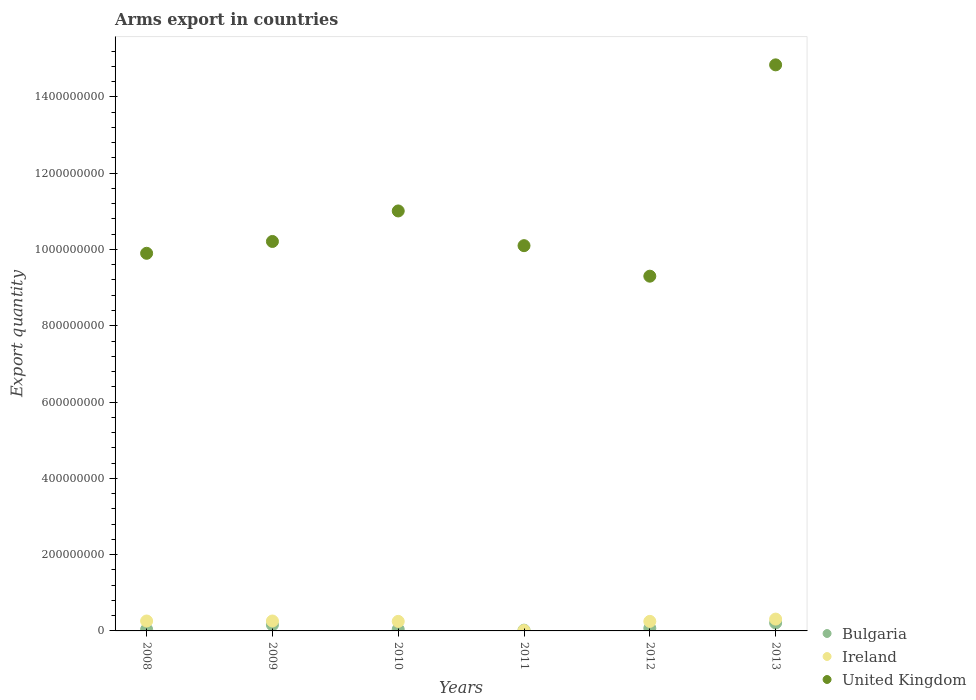How many different coloured dotlines are there?
Give a very brief answer. 3. What is the total arms export in United Kingdom in 2012?
Your response must be concise. 9.30e+08. Across all years, what is the maximum total arms export in Bulgaria?
Provide a short and direct response. 2.10e+07. Across all years, what is the minimum total arms export in Bulgaria?
Ensure brevity in your answer.  2.00e+06. In which year was the total arms export in Bulgaria maximum?
Provide a succinct answer. 2013. What is the total total arms export in United Kingdom in the graph?
Provide a succinct answer. 6.54e+09. What is the difference between the total arms export in United Kingdom in 2010 and that in 2011?
Offer a terse response. 9.10e+07. What is the difference between the total arms export in Bulgaria in 2011 and the total arms export in Ireland in 2009?
Keep it short and to the point. -2.40e+07. What is the average total arms export in Bulgaria per year?
Provide a succinct answer. 9.00e+06. In the year 2011, what is the difference between the total arms export in United Kingdom and total arms export in Ireland?
Ensure brevity in your answer.  1.01e+09. What is the ratio of the total arms export in Bulgaria in 2009 to that in 2012?
Offer a very short reply. 2.29. What is the difference between the highest and the second highest total arms export in Ireland?
Give a very brief answer. 5.00e+06. What is the difference between the highest and the lowest total arms export in United Kingdom?
Ensure brevity in your answer.  5.54e+08. In how many years, is the total arms export in Ireland greater than the average total arms export in Ireland taken over all years?
Offer a very short reply. 5. Is it the case that in every year, the sum of the total arms export in United Kingdom and total arms export in Ireland  is greater than the total arms export in Bulgaria?
Offer a very short reply. Yes. Is the total arms export in Bulgaria strictly less than the total arms export in Ireland over the years?
Provide a short and direct response. No. How many dotlines are there?
Provide a succinct answer. 3. Are the values on the major ticks of Y-axis written in scientific E-notation?
Your answer should be compact. No. Does the graph contain grids?
Keep it short and to the point. No. How are the legend labels stacked?
Keep it short and to the point. Vertical. What is the title of the graph?
Ensure brevity in your answer.  Arms export in countries. What is the label or title of the X-axis?
Offer a terse response. Years. What is the label or title of the Y-axis?
Your answer should be very brief. Export quantity. What is the Export quantity in Bulgaria in 2008?
Your answer should be compact. 4.00e+06. What is the Export quantity in Ireland in 2008?
Offer a very short reply. 2.60e+07. What is the Export quantity of United Kingdom in 2008?
Your response must be concise. 9.90e+08. What is the Export quantity of Bulgaria in 2009?
Provide a short and direct response. 1.60e+07. What is the Export quantity of Ireland in 2009?
Provide a succinct answer. 2.60e+07. What is the Export quantity of United Kingdom in 2009?
Provide a short and direct response. 1.02e+09. What is the Export quantity of Bulgaria in 2010?
Your answer should be very brief. 4.00e+06. What is the Export quantity of Ireland in 2010?
Make the answer very short. 2.50e+07. What is the Export quantity in United Kingdom in 2010?
Your answer should be very brief. 1.10e+09. What is the Export quantity in Ireland in 2011?
Give a very brief answer. 1.00e+06. What is the Export quantity of United Kingdom in 2011?
Make the answer very short. 1.01e+09. What is the Export quantity of Ireland in 2012?
Ensure brevity in your answer.  2.50e+07. What is the Export quantity in United Kingdom in 2012?
Provide a succinct answer. 9.30e+08. What is the Export quantity of Bulgaria in 2013?
Your answer should be very brief. 2.10e+07. What is the Export quantity of Ireland in 2013?
Your response must be concise. 3.10e+07. What is the Export quantity in United Kingdom in 2013?
Make the answer very short. 1.48e+09. Across all years, what is the maximum Export quantity of Bulgaria?
Offer a very short reply. 2.10e+07. Across all years, what is the maximum Export quantity in Ireland?
Offer a very short reply. 3.10e+07. Across all years, what is the maximum Export quantity of United Kingdom?
Make the answer very short. 1.48e+09. Across all years, what is the minimum Export quantity of United Kingdom?
Make the answer very short. 9.30e+08. What is the total Export quantity in Bulgaria in the graph?
Offer a terse response. 5.40e+07. What is the total Export quantity in Ireland in the graph?
Make the answer very short. 1.34e+08. What is the total Export quantity in United Kingdom in the graph?
Provide a short and direct response. 6.54e+09. What is the difference between the Export quantity in Bulgaria in 2008 and that in 2009?
Provide a short and direct response. -1.20e+07. What is the difference between the Export quantity in Ireland in 2008 and that in 2009?
Make the answer very short. 0. What is the difference between the Export quantity of United Kingdom in 2008 and that in 2009?
Keep it short and to the point. -3.10e+07. What is the difference between the Export quantity of Bulgaria in 2008 and that in 2010?
Provide a succinct answer. 0. What is the difference between the Export quantity in Ireland in 2008 and that in 2010?
Keep it short and to the point. 1.00e+06. What is the difference between the Export quantity of United Kingdom in 2008 and that in 2010?
Your answer should be compact. -1.11e+08. What is the difference between the Export quantity in Bulgaria in 2008 and that in 2011?
Your answer should be compact. 2.00e+06. What is the difference between the Export quantity in Ireland in 2008 and that in 2011?
Offer a very short reply. 2.50e+07. What is the difference between the Export quantity of United Kingdom in 2008 and that in 2011?
Your answer should be compact. -2.00e+07. What is the difference between the Export quantity of United Kingdom in 2008 and that in 2012?
Your answer should be very brief. 6.00e+07. What is the difference between the Export quantity in Bulgaria in 2008 and that in 2013?
Make the answer very short. -1.70e+07. What is the difference between the Export quantity of Ireland in 2008 and that in 2013?
Ensure brevity in your answer.  -5.00e+06. What is the difference between the Export quantity in United Kingdom in 2008 and that in 2013?
Ensure brevity in your answer.  -4.94e+08. What is the difference between the Export quantity in United Kingdom in 2009 and that in 2010?
Your response must be concise. -8.00e+07. What is the difference between the Export quantity in Bulgaria in 2009 and that in 2011?
Offer a terse response. 1.40e+07. What is the difference between the Export quantity of Ireland in 2009 and that in 2011?
Your answer should be very brief. 2.50e+07. What is the difference between the Export quantity of United Kingdom in 2009 and that in 2011?
Your answer should be very brief. 1.10e+07. What is the difference between the Export quantity in Bulgaria in 2009 and that in 2012?
Offer a terse response. 9.00e+06. What is the difference between the Export quantity of United Kingdom in 2009 and that in 2012?
Offer a very short reply. 9.10e+07. What is the difference between the Export quantity of Bulgaria in 2009 and that in 2013?
Offer a terse response. -5.00e+06. What is the difference between the Export quantity of Ireland in 2009 and that in 2013?
Make the answer very short. -5.00e+06. What is the difference between the Export quantity of United Kingdom in 2009 and that in 2013?
Provide a short and direct response. -4.63e+08. What is the difference between the Export quantity of Bulgaria in 2010 and that in 2011?
Your response must be concise. 2.00e+06. What is the difference between the Export quantity of Ireland in 2010 and that in 2011?
Provide a succinct answer. 2.40e+07. What is the difference between the Export quantity in United Kingdom in 2010 and that in 2011?
Offer a very short reply. 9.10e+07. What is the difference between the Export quantity of United Kingdom in 2010 and that in 2012?
Your answer should be compact. 1.71e+08. What is the difference between the Export quantity of Bulgaria in 2010 and that in 2013?
Offer a terse response. -1.70e+07. What is the difference between the Export quantity of Ireland in 2010 and that in 2013?
Offer a very short reply. -6.00e+06. What is the difference between the Export quantity in United Kingdom in 2010 and that in 2013?
Your answer should be very brief. -3.83e+08. What is the difference between the Export quantity of Bulgaria in 2011 and that in 2012?
Give a very brief answer. -5.00e+06. What is the difference between the Export quantity of Ireland in 2011 and that in 2012?
Provide a short and direct response. -2.40e+07. What is the difference between the Export quantity of United Kingdom in 2011 and that in 2012?
Make the answer very short. 8.00e+07. What is the difference between the Export quantity in Bulgaria in 2011 and that in 2013?
Offer a very short reply. -1.90e+07. What is the difference between the Export quantity of Ireland in 2011 and that in 2013?
Ensure brevity in your answer.  -3.00e+07. What is the difference between the Export quantity of United Kingdom in 2011 and that in 2013?
Make the answer very short. -4.74e+08. What is the difference between the Export quantity in Bulgaria in 2012 and that in 2013?
Your answer should be compact. -1.40e+07. What is the difference between the Export quantity of Ireland in 2012 and that in 2013?
Make the answer very short. -6.00e+06. What is the difference between the Export quantity of United Kingdom in 2012 and that in 2013?
Keep it short and to the point. -5.54e+08. What is the difference between the Export quantity in Bulgaria in 2008 and the Export quantity in Ireland in 2009?
Your response must be concise. -2.20e+07. What is the difference between the Export quantity of Bulgaria in 2008 and the Export quantity of United Kingdom in 2009?
Your response must be concise. -1.02e+09. What is the difference between the Export quantity in Ireland in 2008 and the Export quantity in United Kingdom in 2009?
Give a very brief answer. -9.95e+08. What is the difference between the Export quantity of Bulgaria in 2008 and the Export quantity of Ireland in 2010?
Offer a terse response. -2.10e+07. What is the difference between the Export quantity of Bulgaria in 2008 and the Export quantity of United Kingdom in 2010?
Offer a terse response. -1.10e+09. What is the difference between the Export quantity of Ireland in 2008 and the Export quantity of United Kingdom in 2010?
Provide a short and direct response. -1.08e+09. What is the difference between the Export quantity in Bulgaria in 2008 and the Export quantity in Ireland in 2011?
Make the answer very short. 3.00e+06. What is the difference between the Export quantity in Bulgaria in 2008 and the Export quantity in United Kingdom in 2011?
Give a very brief answer. -1.01e+09. What is the difference between the Export quantity of Ireland in 2008 and the Export quantity of United Kingdom in 2011?
Offer a terse response. -9.84e+08. What is the difference between the Export quantity of Bulgaria in 2008 and the Export quantity of Ireland in 2012?
Provide a succinct answer. -2.10e+07. What is the difference between the Export quantity of Bulgaria in 2008 and the Export quantity of United Kingdom in 2012?
Provide a succinct answer. -9.26e+08. What is the difference between the Export quantity of Ireland in 2008 and the Export quantity of United Kingdom in 2012?
Your answer should be compact. -9.04e+08. What is the difference between the Export quantity in Bulgaria in 2008 and the Export quantity in Ireland in 2013?
Ensure brevity in your answer.  -2.70e+07. What is the difference between the Export quantity in Bulgaria in 2008 and the Export quantity in United Kingdom in 2013?
Provide a short and direct response. -1.48e+09. What is the difference between the Export quantity in Ireland in 2008 and the Export quantity in United Kingdom in 2013?
Ensure brevity in your answer.  -1.46e+09. What is the difference between the Export quantity of Bulgaria in 2009 and the Export quantity of Ireland in 2010?
Your answer should be very brief. -9.00e+06. What is the difference between the Export quantity in Bulgaria in 2009 and the Export quantity in United Kingdom in 2010?
Ensure brevity in your answer.  -1.08e+09. What is the difference between the Export quantity of Ireland in 2009 and the Export quantity of United Kingdom in 2010?
Give a very brief answer. -1.08e+09. What is the difference between the Export quantity in Bulgaria in 2009 and the Export quantity in Ireland in 2011?
Provide a short and direct response. 1.50e+07. What is the difference between the Export quantity of Bulgaria in 2009 and the Export quantity of United Kingdom in 2011?
Ensure brevity in your answer.  -9.94e+08. What is the difference between the Export quantity in Ireland in 2009 and the Export quantity in United Kingdom in 2011?
Provide a short and direct response. -9.84e+08. What is the difference between the Export quantity of Bulgaria in 2009 and the Export quantity of Ireland in 2012?
Give a very brief answer. -9.00e+06. What is the difference between the Export quantity of Bulgaria in 2009 and the Export quantity of United Kingdom in 2012?
Keep it short and to the point. -9.14e+08. What is the difference between the Export quantity in Ireland in 2009 and the Export quantity in United Kingdom in 2012?
Keep it short and to the point. -9.04e+08. What is the difference between the Export quantity in Bulgaria in 2009 and the Export quantity in Ireland in 2013?
Your answer should be very brief. -1.50e+07. What is the difference between the Export quantity in Bulgaria in 2009 and the Export quantity in United Kingdom in 2013?
Your answer should be compact. -1.47e+09. What is the difference between the Export quantity in Ireland in 2009 and the Export quantity in United Kingdom in 2013?
Your response must be concise. -1.46e+09. What is the difference between the Export quantity of Bulgaria in 2010 and the Export quantity of United Kingdom in 2011?
Offer a terse response. -1.01e+09. What is the difference between the Export quantity in Ireland in 2010 and the Export quantity in United Kingdom in 2011?
Make the answer very short. -9.85e+08. What is the difference between the Export quantity of Bulgaria in 2010 and the Export quantity of Ireland in 2012?
Offer a very short reply. -2.10e+07. What is the difference between the Export quantity of Bulgaria in 2010 and the Export quantity of United Kingdom in 2012?
Make the answer very short. -9.26e+08. What is the difference between the Export quantity of Ireland in 2010 and the Export quantity of United Kingdom in 2012?
Make the answer very short. -9.05e+08. What is the difference between the Export quantity in Bulgaria in 2010 and the Export quantity in Ireland in 2013?
Offer a very short reply. -2.70e+07. What is the difference between the Export quantity in Bulgaria in 2010 and the Export quantity in United Kingdom in 2013?
Your answer should be very brief. -1.48e+09. What is the difference between the Export quantity of Ireland in 2010 and the Export quantity of United Kingdom in 2013?
Ensure brevity in your answer.  -1.46e+09. What is the difference between the Export quantity in Bulgaria in 2011 and the Export quantity in Ireland in 2012?
Keep it short and to the point. -2.30e+07. What is the difference between the Export quantity of Bulgaria in 2011 and the Export quantity of United Kingdom in 2012?
Offer a very short reply. -9.28e+08. What is the difference between the Export quantity in Ireland in 2011 and the Export quantity in United Kingdom in 2012?
Your answer should be very brief. -9.29e+08. What is the difference between the Export quantity in Bulgaria in 2011 and the Export quantity in Ireland in 2013?
Provide a short and direct response. -2.90e+07. What is the difference between the Export quantity of Bulgaria in 2011 and the Export quantity of United Kingdom in 2013?
Ensure brevity in your answer.  -1.48e+09. What is the difference between the Export quantity of Ireland in 2011 and the Export quantity of United Kingdom in 2013?
Ensure brevity in your answer.  -1.48e+09. What is the difference between the Export quantity in Bulgaria in 2012 and the Export quantity in Ireland in 2013?
Provide a short and direct response. -2.40e+07. What is the difference between the Export quantity of Bulgaria in 2012 and the Export quantity of United Kingdom in 2013?
Ensure brevity in your answer.  -1.48e+09. What is the difference between the Export quantity of Ireland in 2012 and the Export quantity of United Kingdom in 2013?
Ensure brevity in your answer.  -1.46e+09. What is the average Export quantity of Bulgaria per year?
Offer a terse response. 9.00e+06. What is the average Export quantity in Ireland per year?
Keep it short and to the point. 2.23e+07. What is the average Export quantity in United Kingdom per year?
Provide a short and direct response. 1.09e+09. In the year 2008, what is the difference between the Export quantity in Bulgaria and Export quantity in Ireland?
Your answer should be compact. -2.20e+07. In the year 2008, what is the difference between the Export quantity of Bulgaria and Export quantity of United Kingdom?
Keep it short and to the point. -9.86e+08. In the year 2008, what is the difference between the Export quantity in Ireland and Export quantity in United Kingdom?
Offer a terse response. -9.64e+08. In the year 2009, what is the difference between the Export quantity of Bulgaria and Export quantity of Ireland?
Provide a short and direct response. -1.00e+07. In the year 2009, what is the difference between the Export quantity of Bulgaria and Export quantity of United Kingdom?
Your answer should be compact. -1.00e+09. In the year 2009, what is the difference between the Export quantity of Ireland and Export quantity of United Kingdom?
Your response must be concise. -9.95e+08. In the year 2010, what is the difference between the Export quantity of Bulgaria and Export quantity of Ireland?
Your answer should be very brief. -2.10e+07. In the year 2010, what is the difference between the Export quantity in Bulgaria and Export quantity in United Kingdom?
Your answer should be compact. -1.10e+09. In the year 2010, what is the difference between the Export quantity in Ireland and Export quantity in United Kingdom?
Your response must be concise. -1.08e+09. In the year 2011, what is the difference between the Export quantity of Bulgaria and Export quantity of Ireland?
Provide a short and direct response. 1.00e+06. In the year 2011, what is the difference between the Export quantity of Bulgaria and Export quantity of United Kingdom?
Offer a terse response. -1.01e+09. In the year 2011, what is the difference between the Export quantity in Ireland and Export quantity in United Kingdom?
Your response must be concise. -1.01e+09. In the year 2012, what is the difference between the Export quantity in Bulgaria and Export quantity in Ireland?
Offer a terse response. -1.80e+07. In the year 2012, what is the difference between the Export quantity in Bulgaria and Export quantity in United Kingdom?
Your answer should be very brief. -9.23e+08. In the year 2012, what is the difference between the Export quantity of Ireland and Export quantity of United Kingdom?
Provide a succinct answer. -9.05e+08. In the year 2013, what is the difference between the Export quantity in Bulgaria and Export quantity in Ireland?
Offer a terse response. -1.00e+07. In the year 2013, what is the difference between the Export quantity in Bulgaria and Export quantity in United Kingdom?
Give a very brief answer. -1.46e+09. In the year 2013, what is the difference between the Export quantity of Ireland and Export quantity of United Kingdom?
Ensure brevity in your answer.  -1.45e+09. What is the ratio of the Export quantity in United Kingdom in 2008 to that in 2009?
Make the answer very short. 0.97. What is the ratio of the Export quantity of Ireland in 2008 to that in 2010?
Provide a succinct answer. 1.04. What is the ratio of the Export quantity in United Kingdom in 2008 to that in 2010?
Provide a succinct answer. 0.9. What is the ratio of the Export quantity in Ireland in 2008 to that in 2011?
Your answer should be compact. 26. What is the ratio of the Export quantity in United Kingdom in 2008 to that in 2011?
Give a very brief answer. 0.98. What is the ratio of the Export quantity of Bulgaria in 2008 to that in 2012?
Offer a terse response. 0.57. What is the ratio of the Export quantity of United Kingdom in 2008 to that in 2012?
Offer a terse response. 1.06. What is the ratio of the Export quantity of Bulgaria in 2008 to that in 2013?
Offer a terse response. 0.19. What is the ratio of the Export quantity in Ireland in 2008 to that in 2013?
Your response must be concise. 0.84. What is the ratio of the Export quantity of United Kingdom in 2008 to that in 2013?
Keep it short and to the point. 0.67. What is the ratio of the Export quantity in United Kingdom in 2009 to that in 2010?
Make the answer very short. 0.93. What is the ratio of the Export quantity of United Kingdom in 2009 to that in 2011?
Make the answer very short. 1.01. What is the ratio of the Export quantity of Bulgaria in 2009 to that in 2012?
Ensure brevity in your answer.  2.29. What is the ratio of the Export quantity in United Kingdom in 2009 to that in 2012?
Give a very brief answer. 1.1. What is the ratio of the Export quantity in Bulgaria in 2009 to that in 2013?
Provide a short and direct response. 0.76. What is the ratio of the Export quantity in Ireland in 2009 to that in 2013?
Offer a very short reply. 0.84. What is the ratio of the Export quantity of United Kingdom in 2009 to that in 2013?
Give a very brief answer. 0.69. What is the ratio of the Export quantity in United Kingdom in 2010 to that in 2011?
Offer a very short reply. 1.09. What is the ratio of the Export quantity in United Kingdom in 2010 to that in 2012?
Offer a terse response. 1.18. What is the ratio of the Export quantity in Bulgaria in 2010 to that in 2013?
Keep it short and to the point. 0.19. What is the ratio of the Export quantity in Ireland in 2010 to that in 2013?
Provide a succinct answer. 0.81. What is the ratio of the Export quantity of United Kingdom in 2010 to that in 2013?
Offer a terse response. 0.74. What is the ratio of the Export quantity of Bulgaria in 2011 to that in 2012?
Your answer should be very brief. 0.29. What is the ratio of the Export quantity of Ireland in 2011 to that in 2012?
Provide a short and direct response. 0.04. What is the ratio of the Export quantity in United Kingdom in 2011 to that in 2012?
Keep it short and to the point. 1.09. What is the ratio of the Export quantity of Bulgaria in 2011 to that in 2013?
Offer a very short reply. 0.1. What is the ratio of the Export quantity in Ireland in 2011 to that in 2013?
Give a very brief answer. 0.03. What is the ratio of the Export quantity in United Kingdom in 2011 to that in 2013?
Provide a succinct answer. 0.68. What is the ratio of the Export quantity of Bulgaria in 2012 to that in 2013?
Provide a succinct answer. 0.33. What is the ratio of the Export quantity of Ireland in 2012 to that in 2013?
Give a very brief answer. 0.81. What is the ratio of the Export quantity of United Kingdom in 2012 to that in 2013?
Make the answer very short. 0.63. What is the difference between the highest and the second highest Export quantity in Bulgaria?
Ensure brevity in your answer.  5.00e+06. What is the difference between the highest and the second highest Export quantity of Ireland?
Your answer should be very brief. 5.00e+06. What is the difference between the highest and the second highest Export quantity of United Kingdom?
Offer a terse response. 3.83e+08. What is the difference between the highest and the lowest Export quantity in Bulgaria?
Ensure brevity in your answer.  1.90e+07. What is the difference between the highest and the lowest Export quantity in Ireland?
Make the answer very short. 3.00e+07. What is the difference between the highest and the lowest Export quantity of United Kingdom?
Offer a terse response. 5.54e+08. 